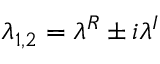Convert formula to latex. <formula><loc_0><loc_0><loc_500><loc_500>\lambda _ { 1 , 2 } = \lambda ^ { R } \pm i \lambda ^ { I }</formula> 